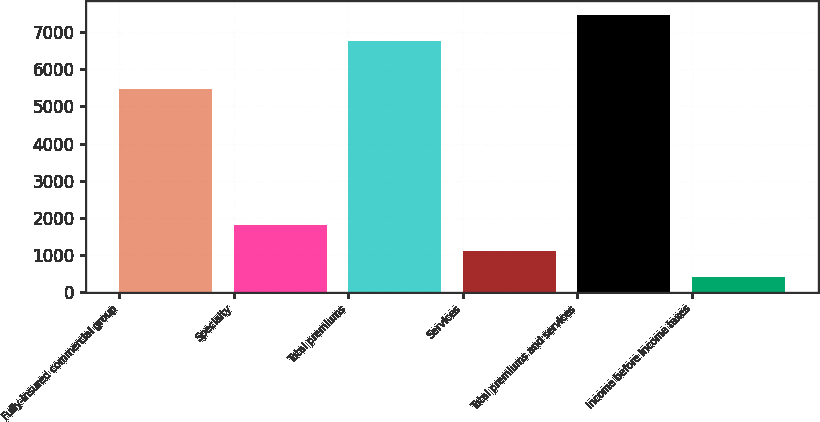<chart> <loc_0><loc_0><loc_500><loc_500><bar_chart><fcel>Fully-insured commercial group<fcel>Specialty<fcel>Total premiums<fcel>Services<fcel>Total premiums and services<fcel>Income before income taxes<nl><fcel>5462<fcel>1809.2<fcel>6772<fcel>1110.6<fcel>7470.6<fcel>412<nl></chart> 